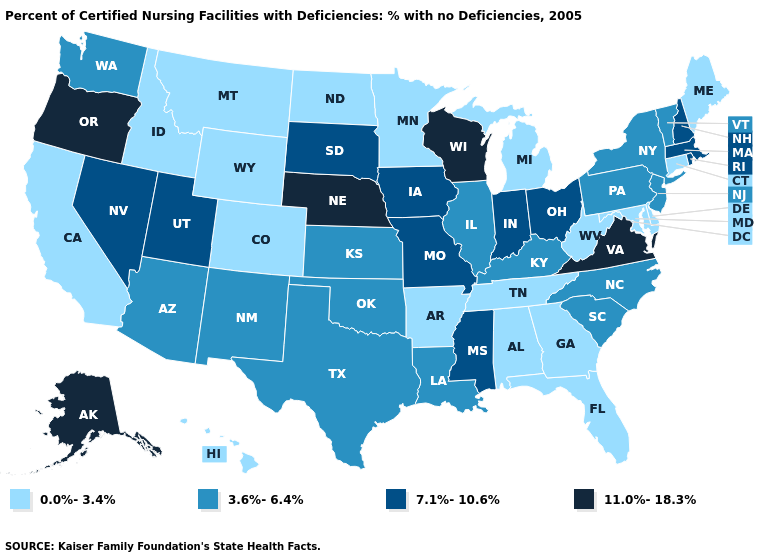What is the value of Illinois?
Quick response, please. 3.6%-6.4%. What is the lowest value in states that border Montana?
Answer briefly. 0.0%-3.4%. Which states hav the highest value in the West?
Write a very short answer. Alaska, Oregon. Name the states that have a value in the range 0.0%-3.4%?
Concise answer only. Alabama, Arkansas, California, Colorado, Connecticut, Delaware, Florida, Georgia, Hawaii, Idaho, Maine, Maryland, Michigan, Minnesota, Montana, North Dakota, Tennessee, West Virginia, Wyoming. Does New Hampshire have the highest value in the USA?
Be succinct. No. Does the map have missing data?
Concise answer only. No. Name the states that have a value in the range 11.0%-18.3%?
Quick response, please. Alaska, Nebraska, Oregon, Virginia, Wisconsin. Name the states that have a value in the range 3.6%-6.4%?
Keep it brief. Arizona, Illinois, Kansas, Kentucky, Louisiana, New Jersey, New Mexico, New York, North Carolina, Oklahoma, Pennsylvania, South Carolina, Texas, Vermont, Washington. Does Pennsylvania have the same value as Illinois?
Answer briefly. Yes. Which states hav the highest value in the Northeast?
Short answer required. Massachusetts, New Hampshire, Rhode Island. What is the lowest value in the MidWest?
Keep it brief. 0.0%-3.4%. Name the states that have a value in the range 11.0%-18.3%?
Concise answer only. Alaska, Nebraska, Oregon, Virginia, Wisconsin. Name the states that have a value in the range 11.0%-18.3%?
Give a very brief answer. Alaska, Nebraska, Oregon, Virginia, Wisconsin. What is the value of North Dakota?
Quick response, please. 0.0%-3.4%. What is the value of Kansas?
Quick response, please. 3.6%-6.4%. 